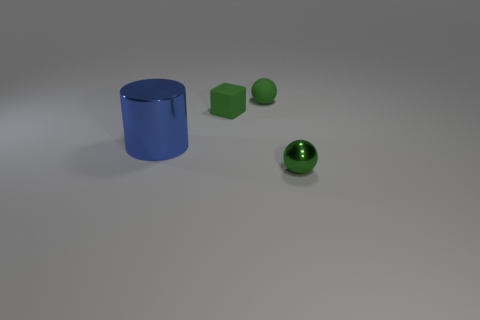The shiny thing that is the same color as the matte cube is what shape?
Give a very brief answer. Sphere. What is the size of the other thing that is the same shape as the green metallic thing?
Your answer should be very brief. Small. Does the shiny thing that is behind the green shiny object have the same shape as the small metallic thing?
Your answer should be compact. No. What color is the shiny thing behind the tiny shiny thing?
Your answer should be compact. Blue. What number of other objects are the same size as the green metallic ball?
Keep it short and to the point. 2. Is there anything else that is the same shape as the small metal thing?
Your response must be concise. Yes. Is the number of metallic cylinders that are right of the cylinder the same as the number of objects?
Provide a succinct answer. No. What number of other green things are the same material as the big object?
Your answer should be very brief. 1. What color is the small ball that is made of the same material as the large blue cylinder?
Your response must be concise. Green. Is the tiny green metal object the same shape as the big blue shiny thing?
Keep it short and to the point. No. 